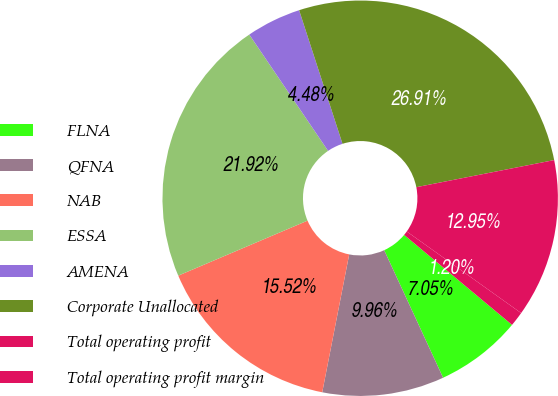<chart> <loc_0><loc_0><loc_500><loc_500><pie_chart><fcel>FLNA<fcel>QFNA<fcel>NAB<fcel>ESSA<fcel>AMENA<fcel>Corporate Unallocated<fcel>Total operating profit<fcel>Total operating profit margin<nl><fcel>7.05%<fcel>9.96%<fcel>15.52%<fcel>21.92%<fcel>4.48%<fcel>26.9%<fcel>12.95%<fcel>1.2%<nl></chart> 